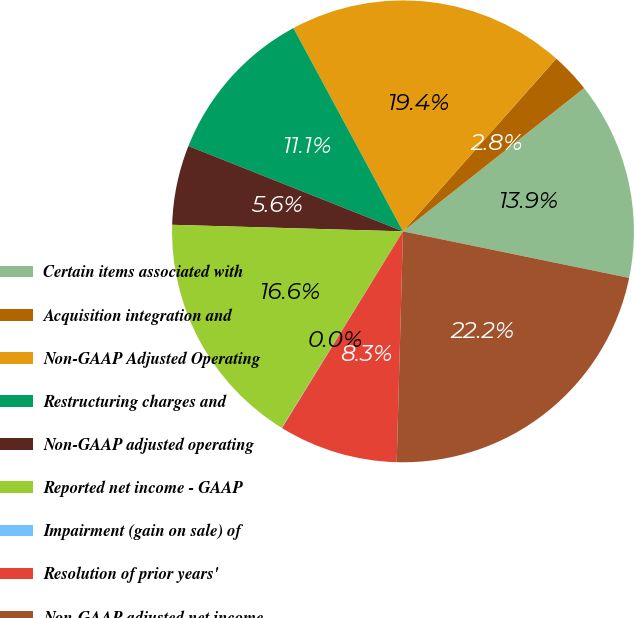Convert chart. <chart><loc_0><loc_0><loc_500><loc_500><pie_chart><fcel>Certain items associated with<fcel>Acquisition integration and<fcel>Non-GAAP Adjusted Operating<fcel>Restructuring charges and<fcel>Non-GAAP adjusted operating<fcel>Reported net income - GAAP<fcel>Impairment (gain on sale) of<fcel>Resolution of prior years'<fcel>Non-GAAP adjusted net income<nl><fcel>13.88%<fcel>2.8%<fcel>19.42%<fcel>11.11%<fcel>5.57%<fcel>16.65%<fcel>0.03%<fcel>8.34%<fcel>22.2%<nl></chart> 